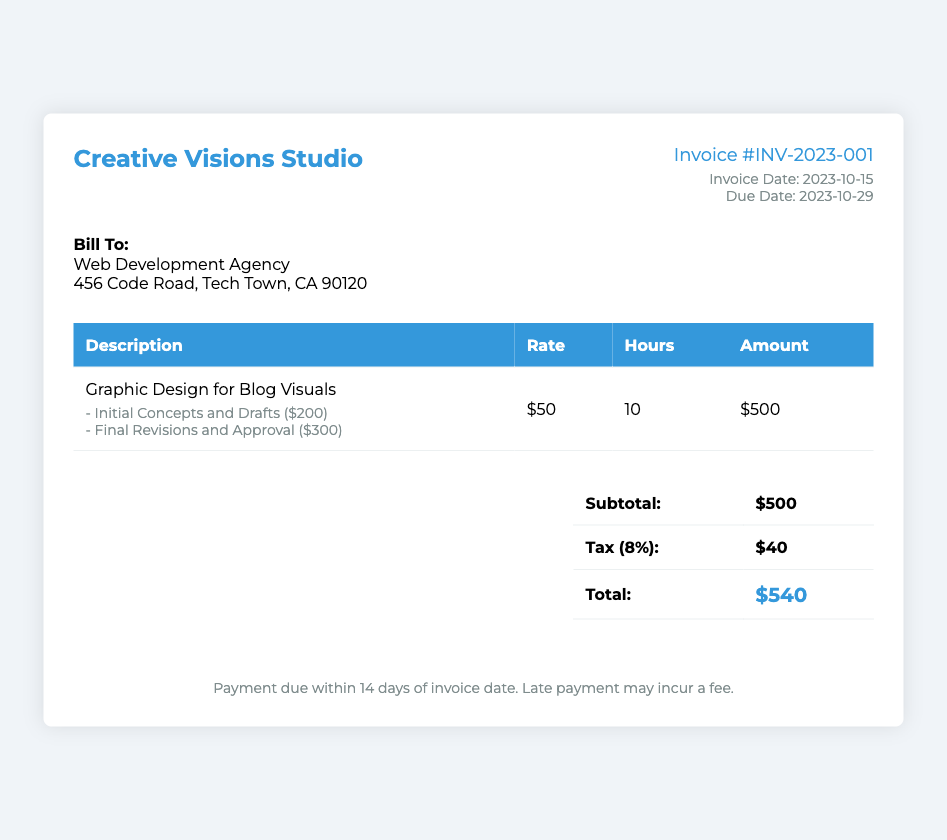What is the invoice number? The invoice number is clearly stated on the document as a unique identifier for billing purposes.
Answer: INV-2023-001 What is the total amount due? The total amount due is the final figure that encompasses all charges detailed in the invoice.
Answer: $540 What is the tax percentage applied? The tax percentage is mentioned in the total section of the document, providing clarity on tax calculations.
Answer: 8% What is the due date for payment? The due date is explicitly indicated in the invoice details section, outlining when the payment should be completed.
Answer: 2023-10-29 How many hours were billed for graphic design services? The total hours billed are specified in the table detailing the graphic design service, offering a breakdown of work time.
Answer: 10 What was the rate for the graphic design service? The hourly rate for the service is documented in the invoice table, allowing for easy calculation of total fees.
Answer: $50 What constitutes the final amount after tax? The final amount includes the subtotal and the tax, clearly calculated and presented in the total section of the invoice.
Answer: $540 What is the subtotal before tax? The subtotal amount before tax is presented clearly in the invoice, summarizing the charges incurred.
Answer: $500 What payment terms are specified? The payment terms detail the conditions under which payment is expected, providing context for payment obligation.
Answer: Payment due within 14 days of invoice date 